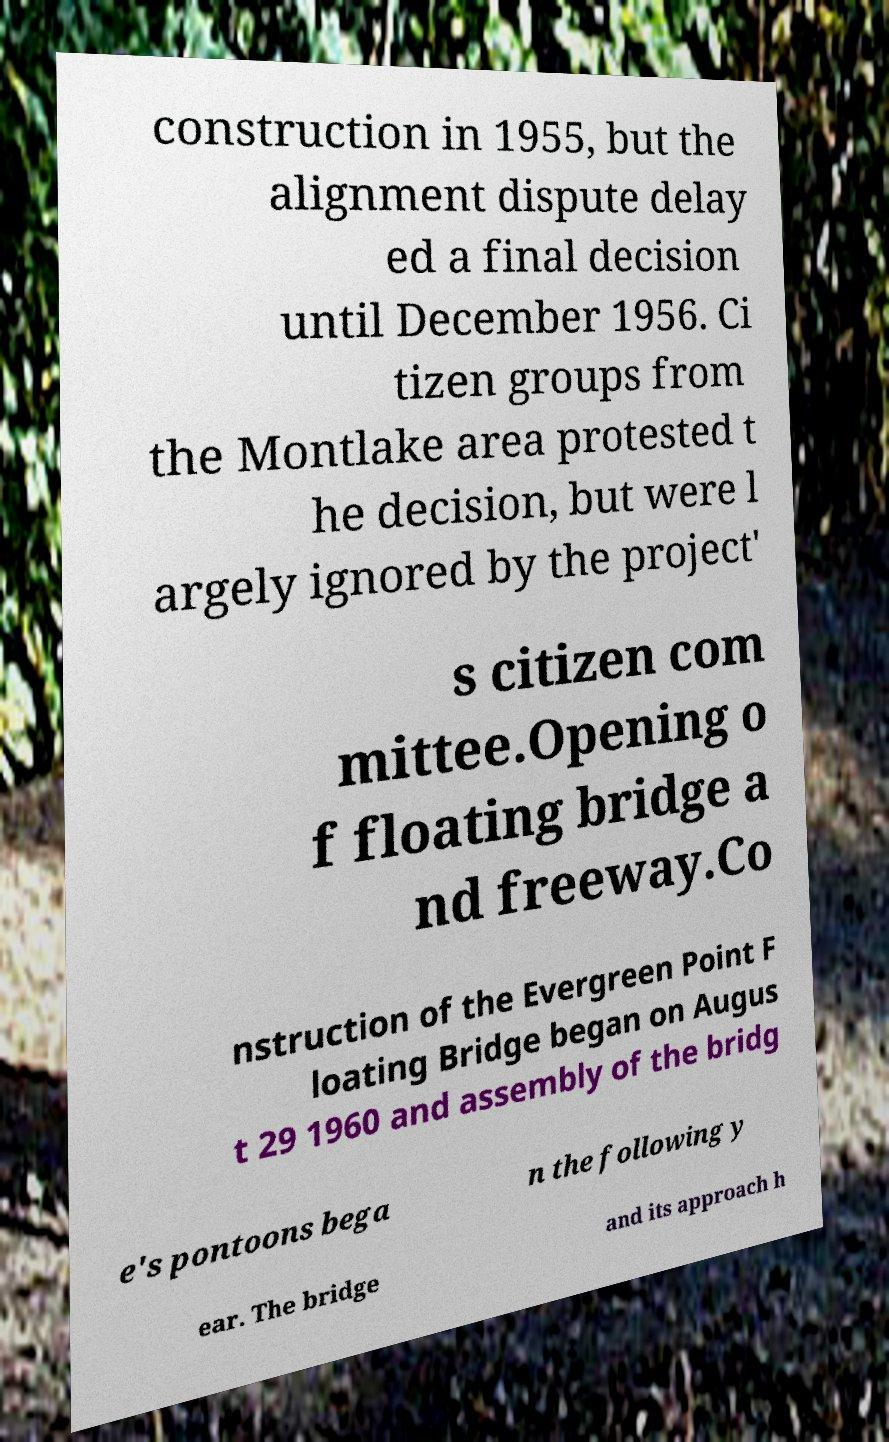There's text embedded in this image that I need extracted. Can you transcribe it verbatim? construction in 1955, but the alignment dispute delay ed a final decision until December 1956. Ci tizen groups from the Montlake area protested t he decision, but were l argely ignored by the project' s citizen com mittee.Opening o f floating bridge a nd freeway.Co nstruction of the Evergreen Point F loating Bridge began on Augus t 29 1960 and assembly of the bridg e's pontoons bega n the following y ear. The bridge and its approach h 